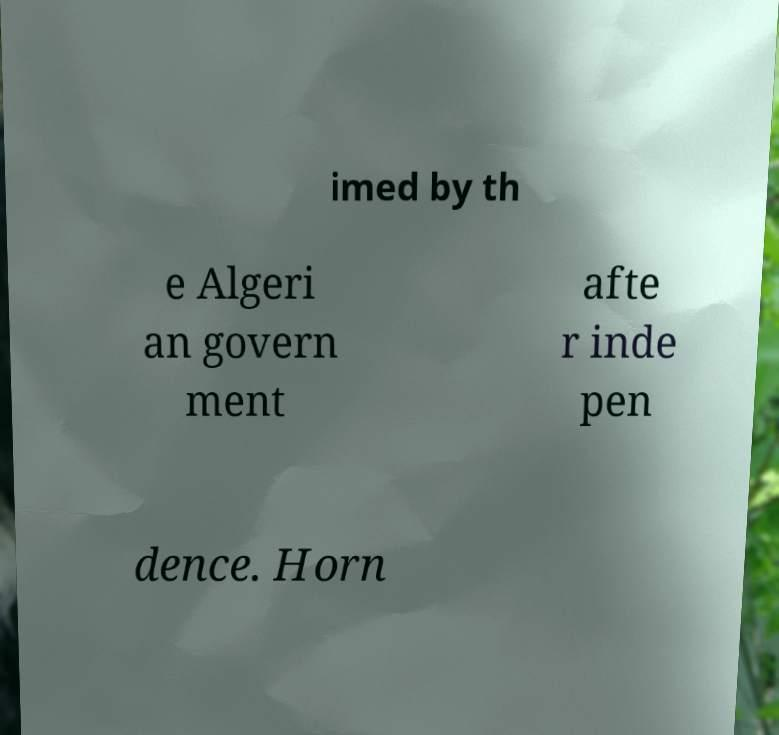There's text embedded in this image that I need extracted. Can you transcribe it verbatim? imed by th e Algeri an govern ment afte r inde pen dence. Horn 